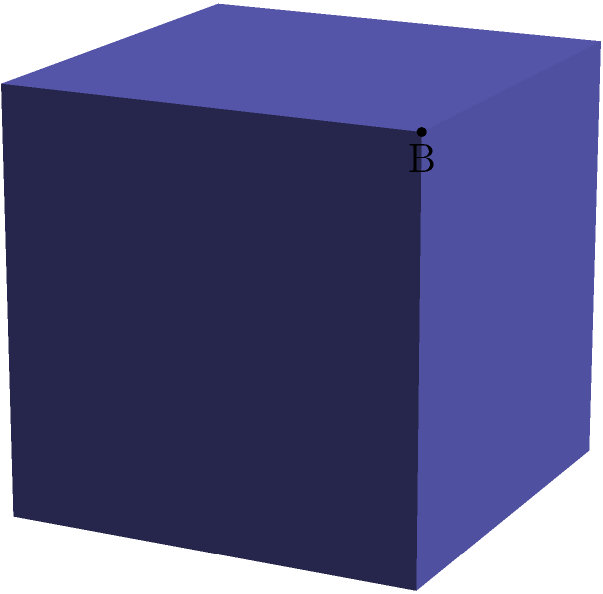In this cube, consider the angle formed between the front face (ABFE) and the top face (EFGH). What is the measure of this angle in degrees? Let's approach this step-by-step:

1) In a cube, all faces are perpendicular to each other. This means that the angle between any two adjacent faces is always 90°.

2) However, we need to be careful here. The question is asking about the angle between two faces, not the angle between the normal vectors of these faces.

3) The relationship between the angle of the faces ($\theta$) and the angle between their normal vectors ($\phi$) is:

   $\theta = 180° - \phi$

4) Since we know that the normal vectors of adjacent faces in a cube are perpendicular (90° apart), we can plug this into our equation:

   $\theta = 180° - 90° = 90°$

5) This result makes intuitive sense: if you were to "open" the cube by rotating one face away from the other, you would need to rotate it by 90° to make it coplanar with the other face.

Therefore, the angle between the front face and the top face of the cube is 90°.
Answer: 90° 